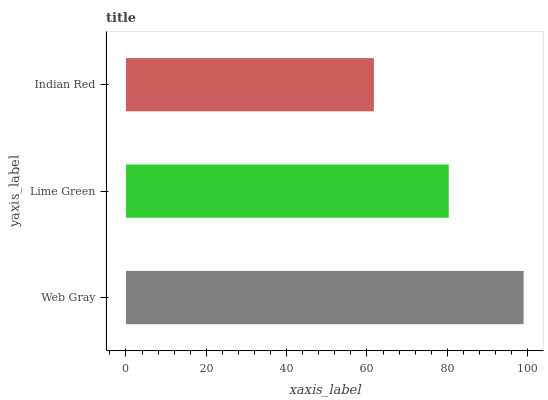Is Indian Red the minimum?
Answer yes or no. Yes. Is Web Gray the maximum?
Answer yes or no. Yes. Is Lime Green the minimum?
Answer yes or no. No. Is Lime Green the maximum?
Answer yes or no. No. Is Web Gray greater than Lime Green?
Answer yes or no. Yes. Is Lime Green less than Web Gray?
Answer yes or no. Yes. Is Lime Green greater than Web Gray?
Answer yes or no. No. Is Web Gray less than Lime Green?
Answer yes or no. No. Is Lime Green the high median?
Answer yes or no. Yes. Is Lime Green the low median?
Answer yes or no. Yes. Is Web Gray the high median?
Answer yes or no. No. Is Indian Red the low median?
Answer yes or no. No. 